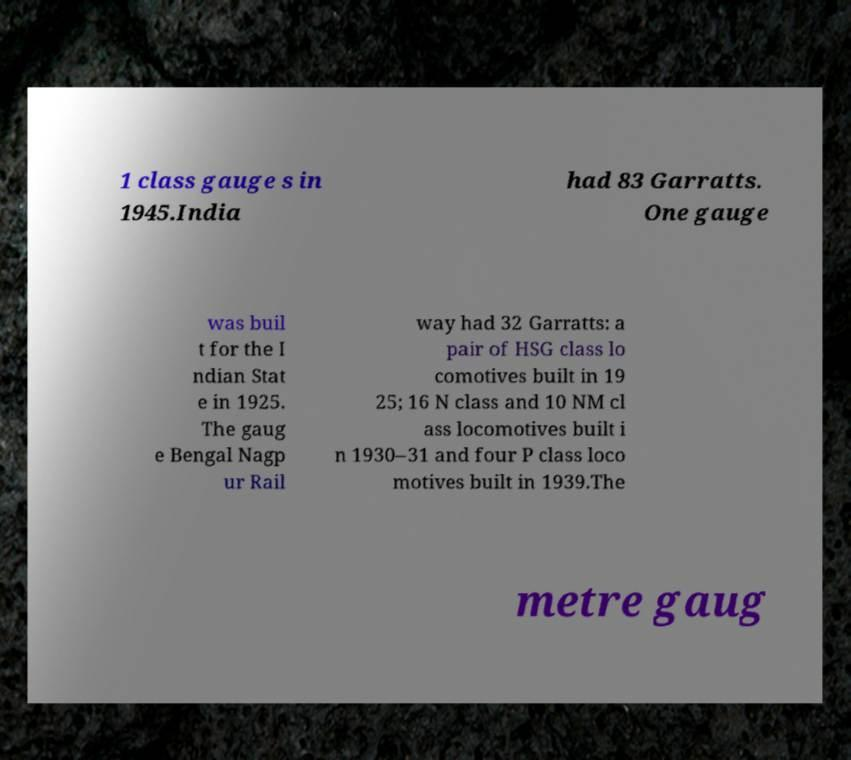What messages or text are displayed in this image? I need them in a readable, typed format. 1 class gauge s in 1945.India had 83 Garratts. One gauge was buil t for the I ndian Stat e in 1925. The gaug e Bengal Nagp ur Rail way had 32 Garratts: a pair of HSG class lo comotives built in 19 25; 16 N class and 10 NM cl ass locomotives built i n 1930–31 and four P class loco motives built in 1939.The metre gaug 